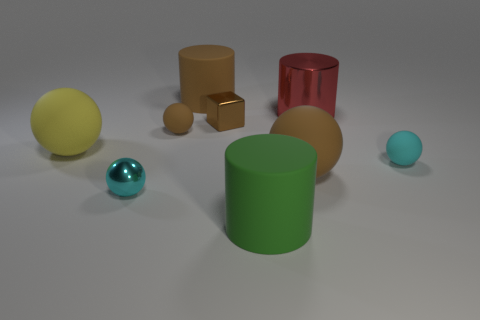There is a matte cylinder that is the same color as the shiny cube; what size is it?
Offer a terse response. Large. How many balls are either large brown rubber objects or tiny brown matte objects?
Provide a succinct answer. 2. How many yellow matte spheres are the same size as the red metal cylinder?
Your answer should be compact. 1. What number of tiny cyan objects are behind the tiny cyan thing to the left of the small block?
Make the answer very short. 1. How big is the metal object that is on the right side of the small brown matte thing and to the left of the big green rubber cylinder?
Make the answer very short. Small. Is the number of brown matte cylinders greater than the number of balls?
Keep it short and to the point. No. Are there any balls that have the same color as the shiny cube?
Your answer should be compact. Yes. There is a cyan thing on the right side of the metallic ball; does it have the same size as the red metal object?
Your response must be concise. No. Are there fewer brown matte cubes than big brown rubber cylinders?
Offer a very short reply. Yes. Are there any cylinders made of the same material as the tiny brown cube?
Make the answer very short. Yes. 